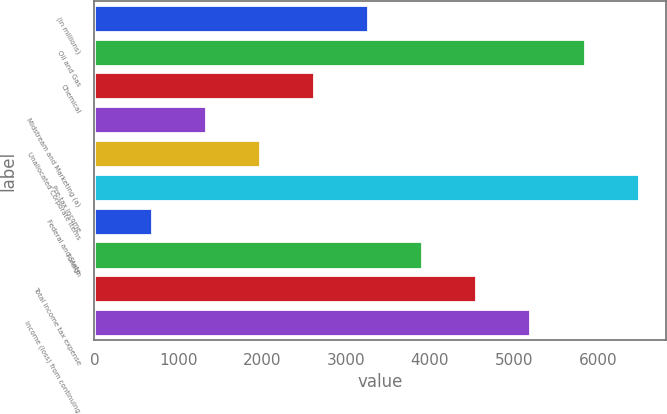<chart> <loc_0><loc_0><loc_500><loc_500><bar_chart><fcel>(in millions)<fcel>Oil and Gas<fcel>Chemical<fcel>Midstream and Marketing (a)<fcel>Unallocated Corporate Items<fcel>Pre-tax income<fcel>Federal and State<fcel>Foreign<fcel>Total income tax expense<fcel>Income (loss) from continuing<nl><fcel>3264.5<fcel>5843.3<fcel>2619.8<fcel>1330.4<fcel>1975.1<fcel>6488<fcel>685.7<fcel>3909.2<fcel>4553.9<fcel>5198.6<nl></chart> 